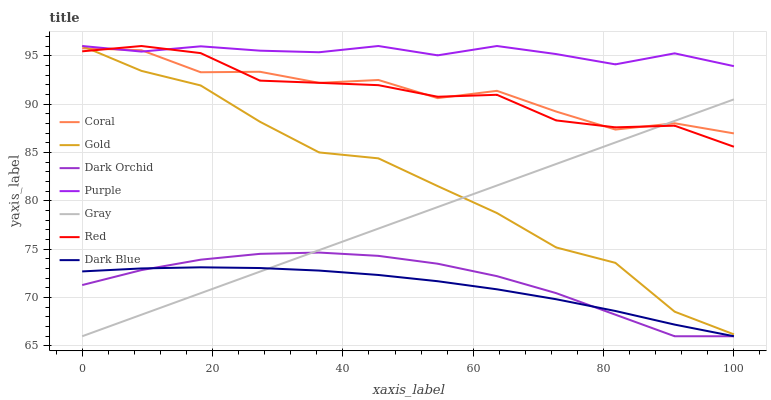Does Dark Blue have the minimum area under the curve?
Answer yes or no. Yes. Does Purple have the maximum area under the curve?
Answer yes or no. Yes. Does Gold have the minimum area under the curve?
Answer yes or no. No. Does Gold have the maximum area under the curve?
Answer yes or no. No. Is Gray the smoothest?
Answer yes or no. Yes. Is Coral the roughest?
Answer yes or no. Yes. Is Gold the smoothest?
Answer yes or no. No. Is Gold the roughest?
Answer yes or no. No. Does Gray have the lowest value?
Answer yes or no. Yes. Does Gold have the lowest value?
Answer yes or no. No. Does Red have the highest value?
Answer yes or no. Yes. Does Coral have the highest value?
Answer yes or no. No. Is Dark Blue less than Gold?
Answer yes or no. Yes. Is Purple greater than Dark Orchid?
Answer yes or no. Yes. Does Dark Orchid intersect Dark Blue?
Answer yes or no. Yes. Is Dark Orchid less than Dark Blue?
Answer yes or no. No. Is Dark Orchid greater than Dark Blue?
Answer yes or no. No. Does Dark Blue intersect Gold?
Answer yes or no. No. 